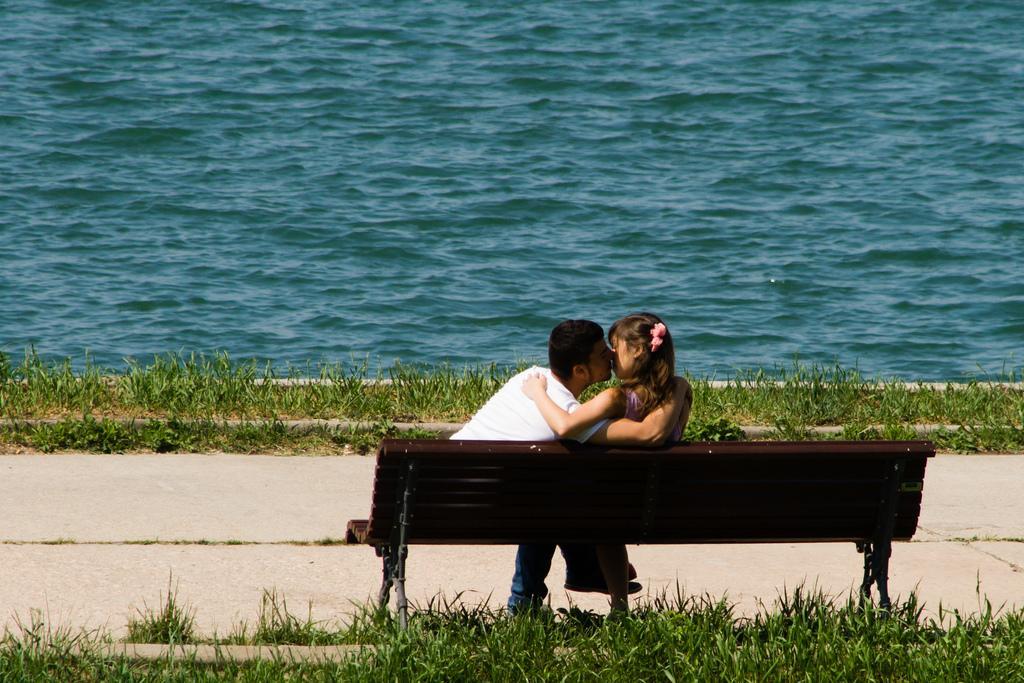In one or two sentences, can you explain what this image depicts? In this image I can see a man and one woman sitting on the bench. On the top of the image I can see water. On the bottom of the image there is grass. 